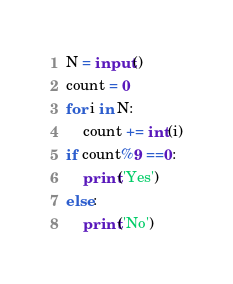Convert code to text. <code><loc_0><loc_0><loc_500><loc_500><_Python_>N = input()
count = 0
for i in N:
    count += int(i)
if count%9 ==0:
    print('Yes')
else:
    print('No')</code> 